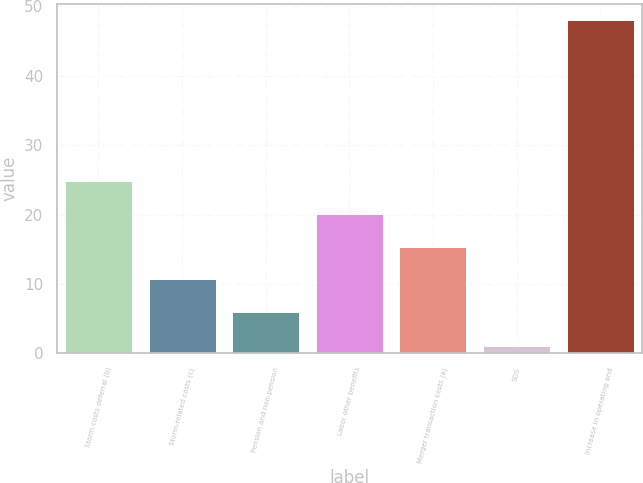Convert chart. <chart><loc_0><loc_0><loc_500><loc_500><bar_chart><fcel>Storm costs deferral (b)<fcel>Storm-related costs (c)<fcel>Pension and non-pension<fcel>Labor other benefits<fcel>Merger transaction costs (a)<fcel>SOS<fcel>Increase in operating and<nl><fcel>24.8<fcel>10.7<fcel>6<fcel>20.1<fcel>15.4<fcel>1<fcel>48<nl></chart> 